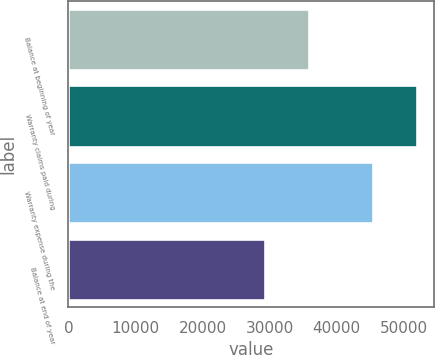Convert chart. <chart><loc_0><loc_0><loc_500><loc_500><bar_chart><fcel>Balance at beginning of year<fcel>Warranty claims paid during<fcel>Warranty expense during the<fcel>Balance at end of year<nl><fcel>35818<fcel>51941<fcel>45473<fcel>29350<nl></chart> 